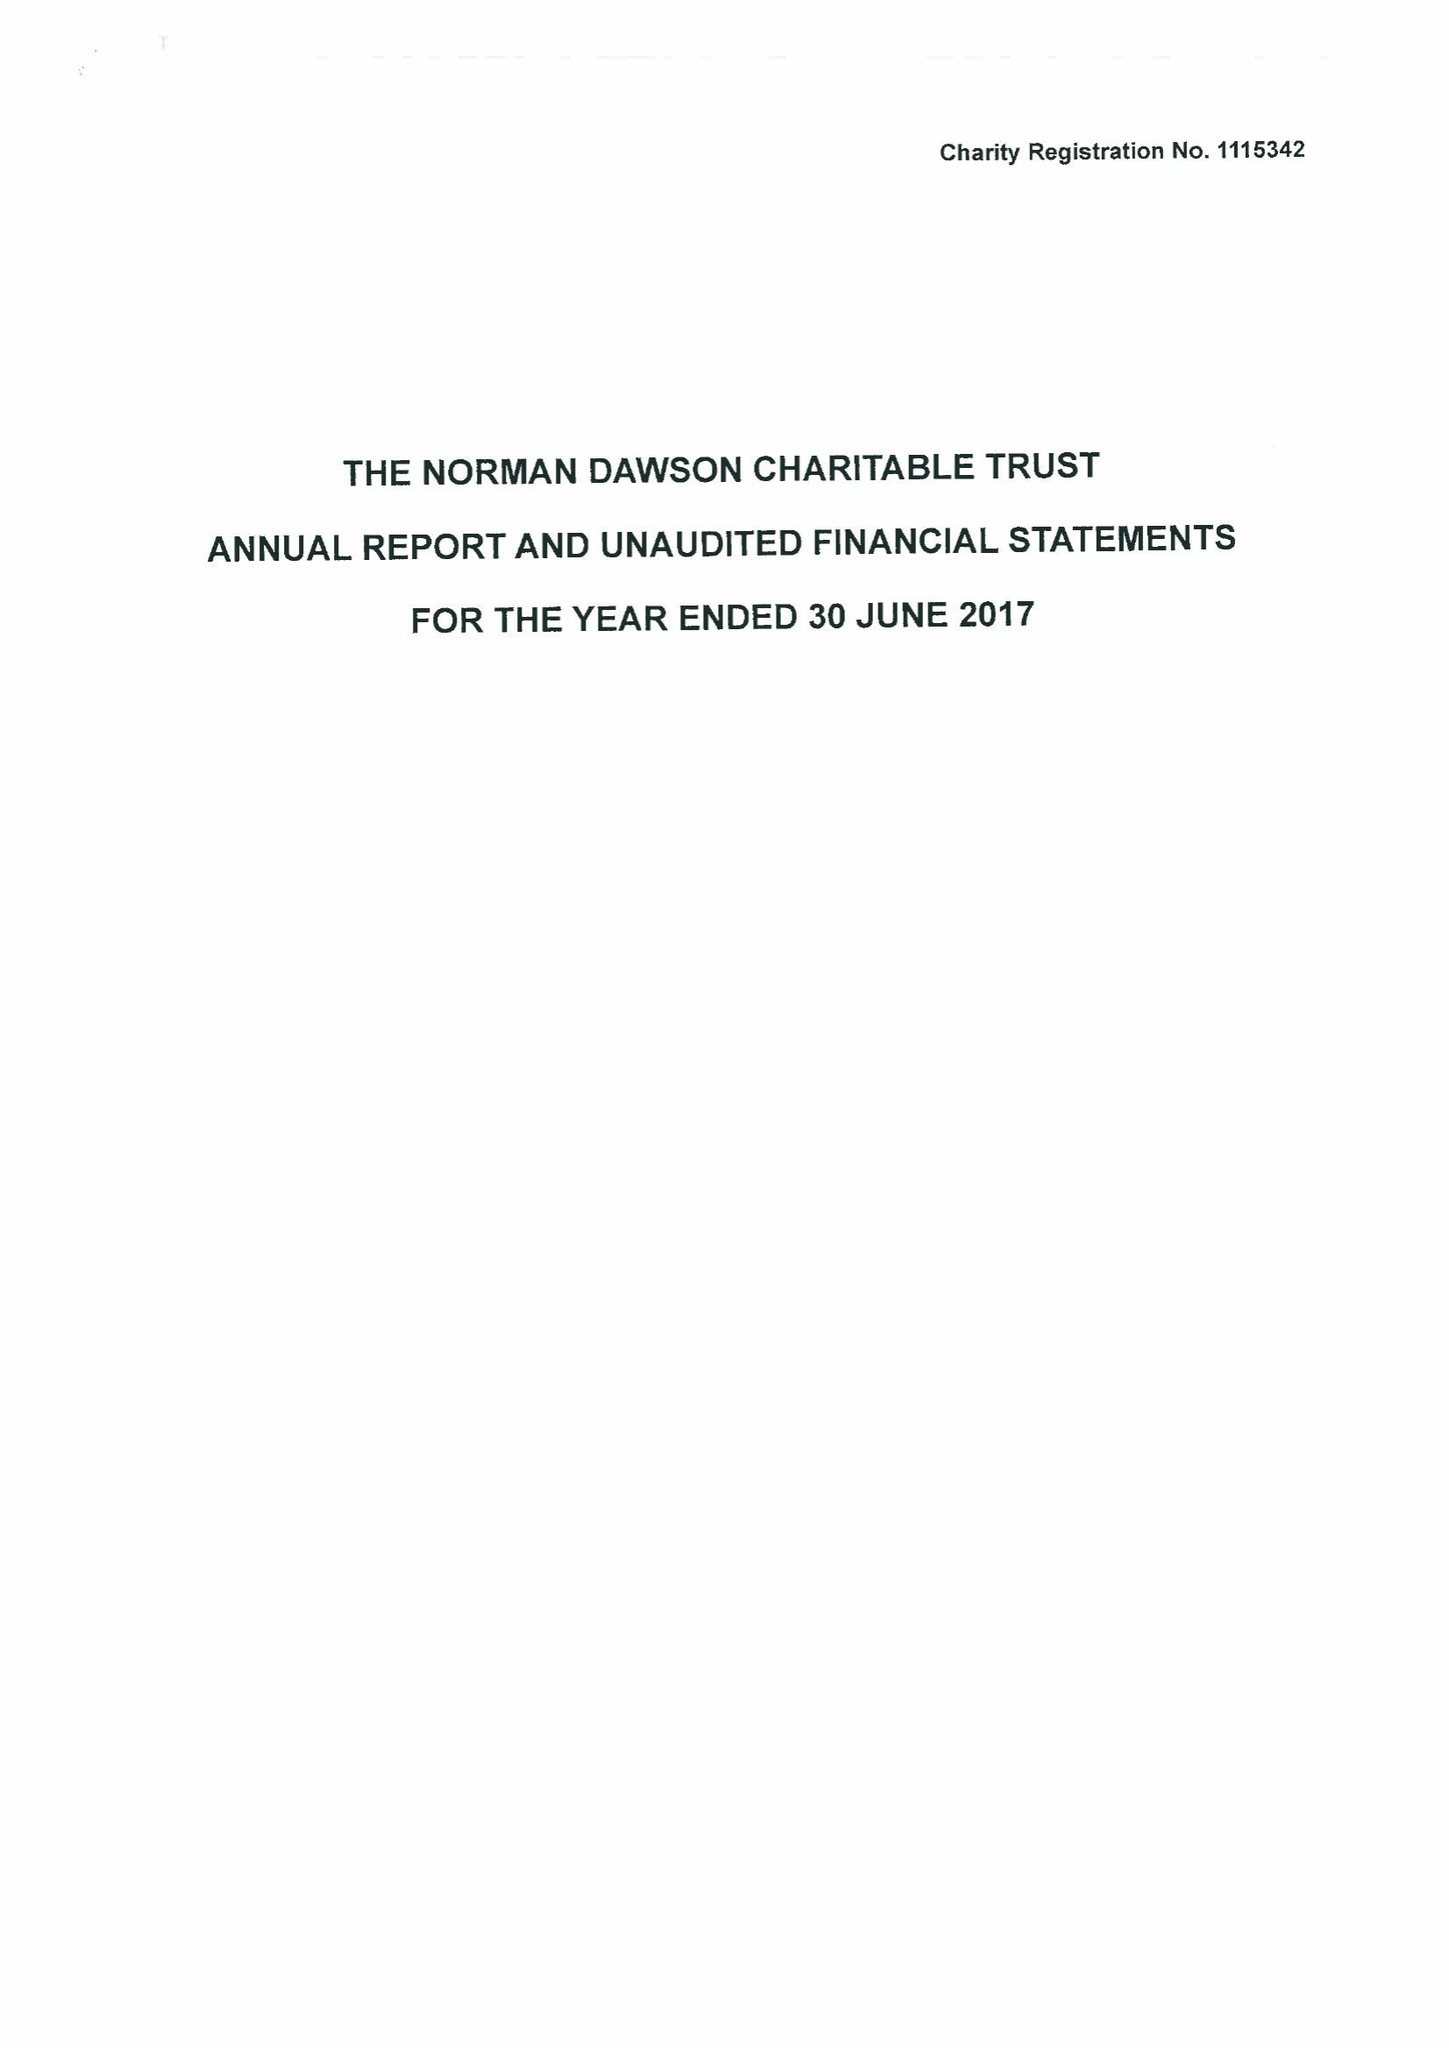What is the value for the address__post_town?
Answer the question using a single word or phrase. KIDDERMINSTER 